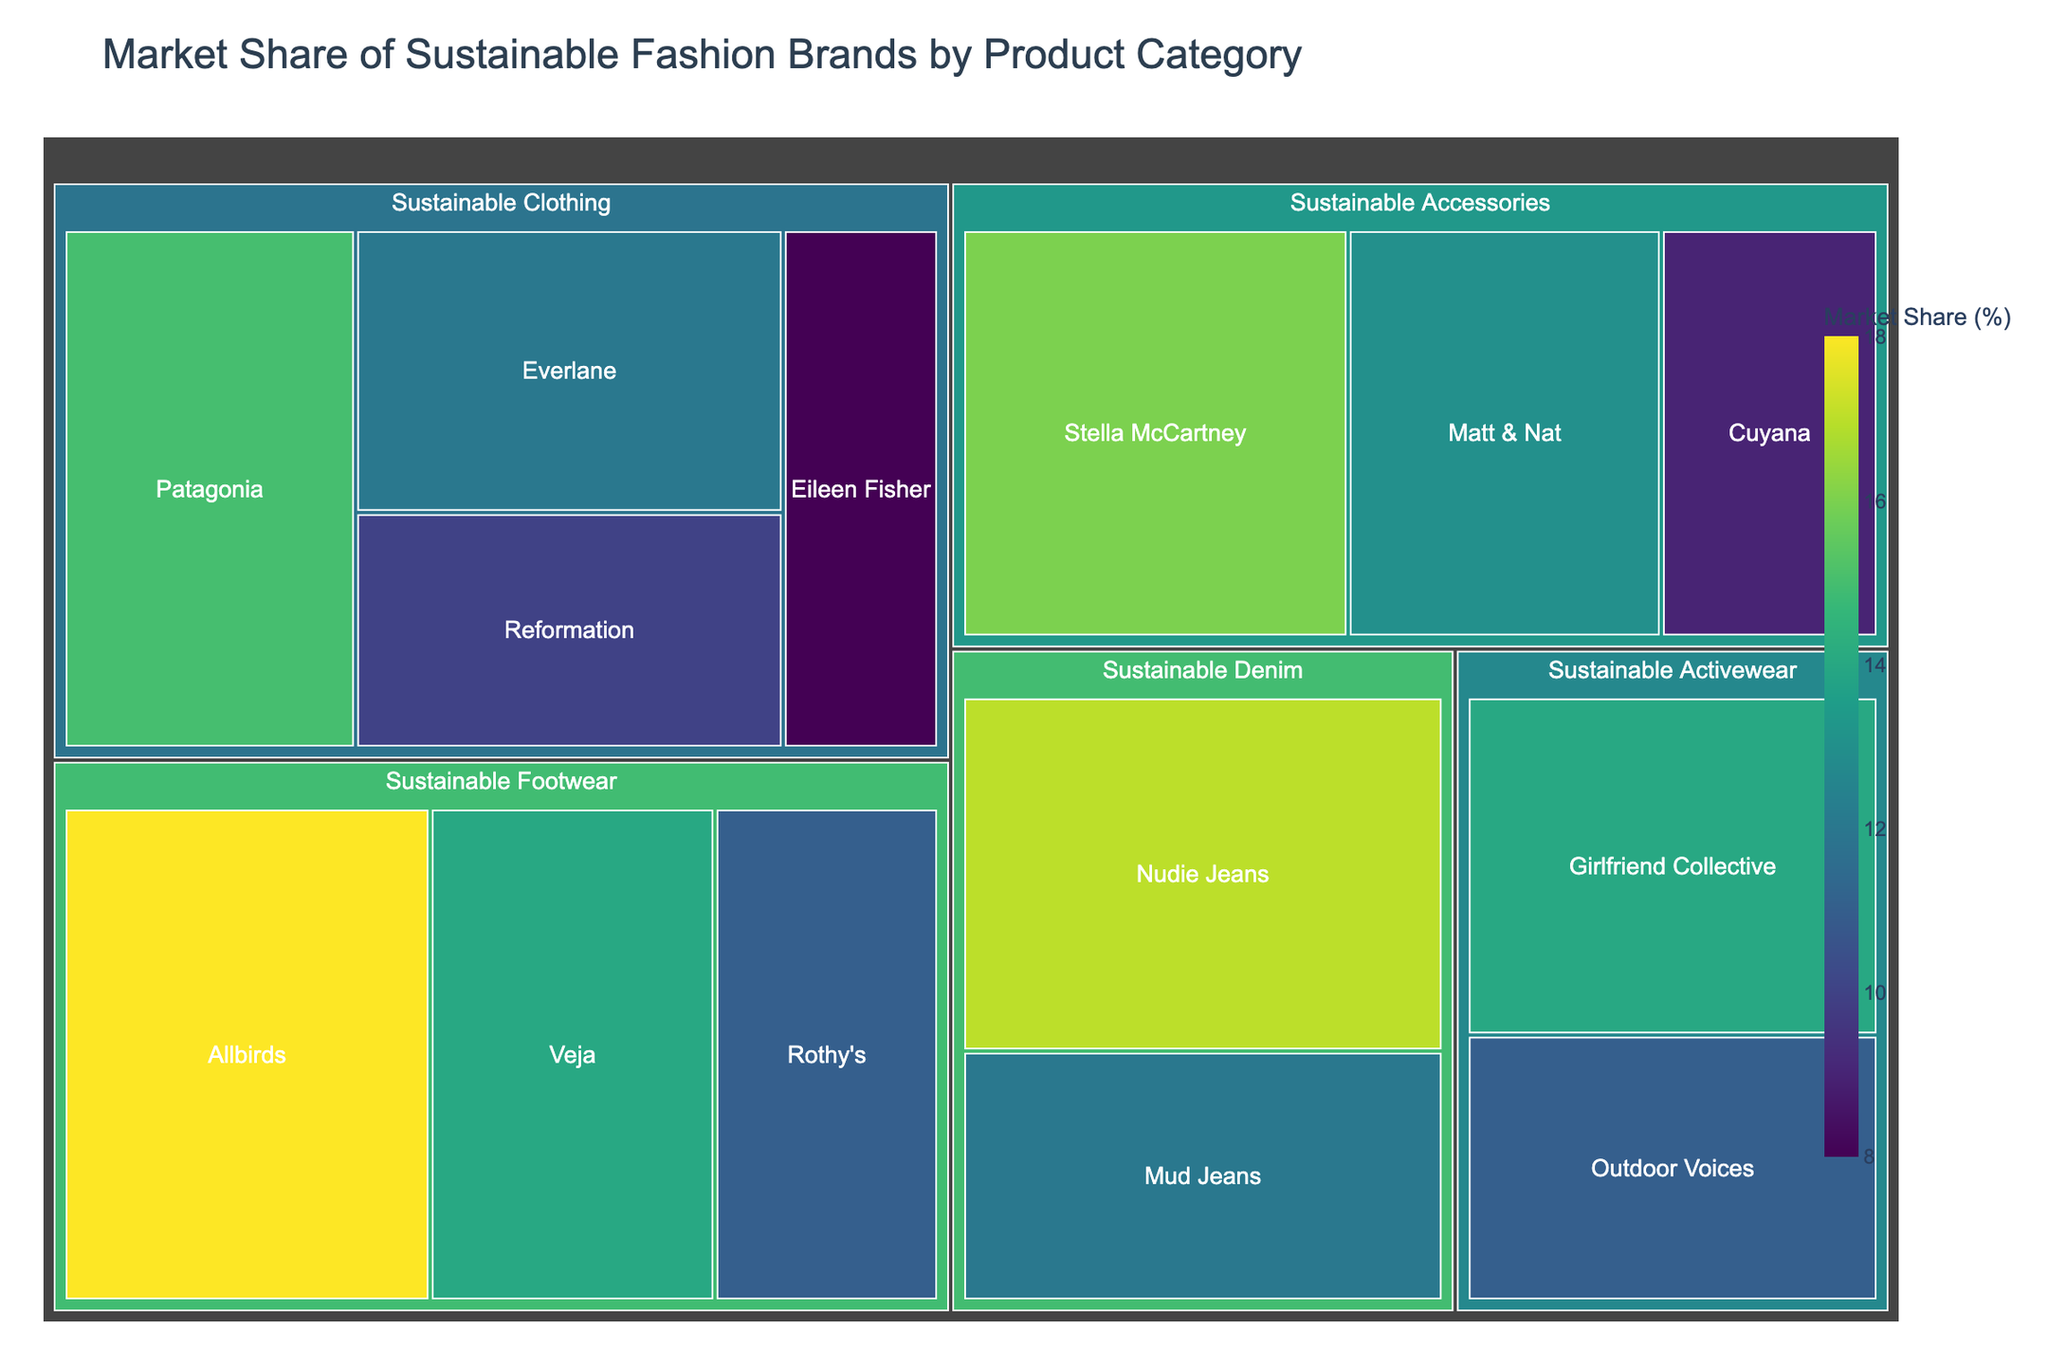Who has the highest market share in Sustainable Clothing? The treemap shows different market shares segregated by product categories. Look at the Sustainable Clothing section and identify the brand with the largest area.
Answer: Patagonia What's the total market share of the Sustainable Footwear category? Add up the individual market shares of Allbirds, Veja, and Rothy's in the Sustainable Footwear section: 18 + 14 + 11.
Answer: 43% Which category has the least diverse brands based on the number of different brands represented? Count the number of brands in each category. The category with the least number of brands is the least diverse.
Answer: Sustainable Denim What's the difference in market share between the leading brands of Sustainable Accessories and Sustainable Activewear? Identify the leading brands in each category (Stella McCartney for Sustainable Accessories and Girlfriend Collective for Sustainable Activewear) and subtract the market share of the leading brand in Sustainable Activewear from the market share of the leading brand in Sustainable Accessories: 16 - 14.
Answer: 2% Which brand within Sustainable Denim has a higher market share, Nudie Jeans or Mud Jeans? Compare the market shares of Nudie Jeans and Mud Jeans in the Sustainable Denim section.
Answer: Nudie Jeans How does the market share of Eileen Fisher in Sustainable Clothing compare to that of Outdoor Voices in Sustainable Activewear? Compare the market shares by examining their sizes in their respective categories: Eileen Fisher has 8%, and Outdoor Voices has 11%.
Answer: Outdoor Voices has 3% more Which brand has the lowest market share in the entire treemap? Look for the brand with the smallest area in the entire treemap, which signifies the lowest market share.
Answer: Cuyana 